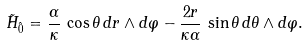<formula> <loc_0><loc_0><loc_500><loc_500>\tilde { H } _ { \hat { 0 } } = { \frac { \alpha } { \kappa } } \, \cos \theta \, d r \wedge d \varphi - { \frac { 2 r } { \kappa \alpha } } \, \sin \theta \, d \theta \wedge d \varphi .</formula> 